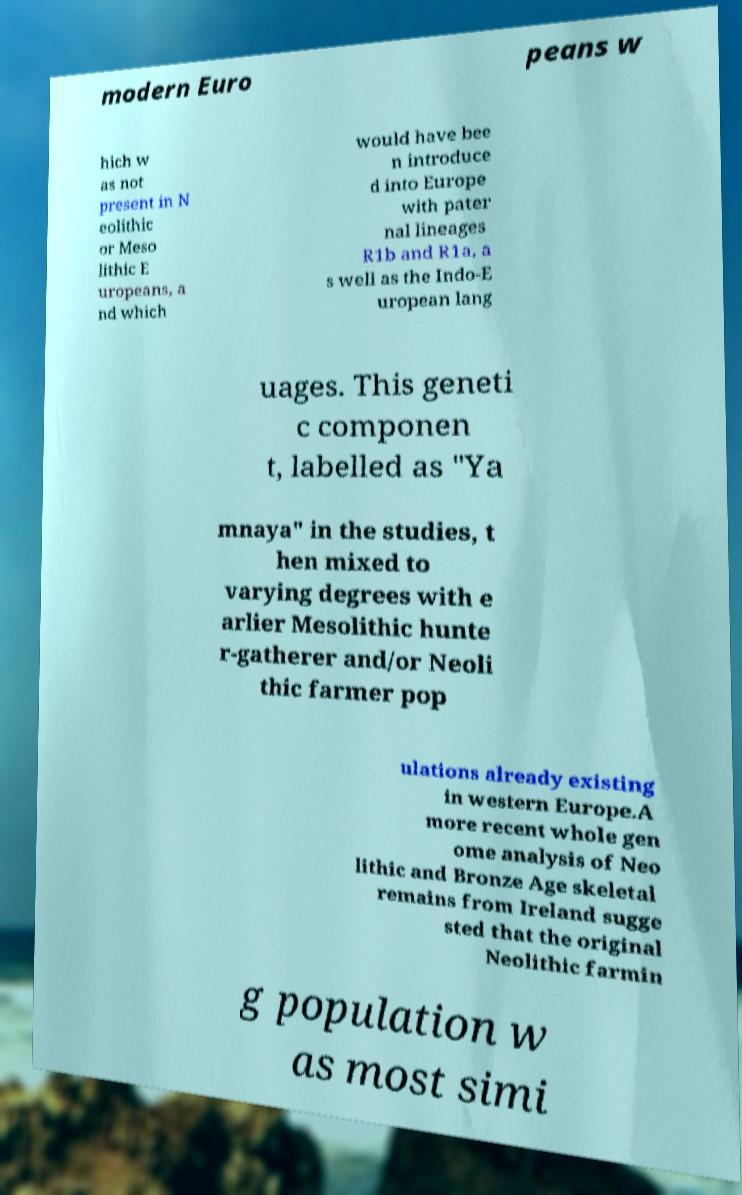For documentation purposes, I need the text within this image transcribed. Could you provide that? modern Euro peans w hich w as not present in N eolithic or Meso lithic E uropeans, a nd which would have bee n introduce d into Europe with pater nal lineages R1b and R1a, a s well as the Indo-E uropean lang uages. This geneti c componen t, labelled as "Ya mnaya" in the studies, t hen mixed to varying degrees with e arlier Mesolithic hunte r-gatherer and/or Neoli thic farmer pop ulations already existing in western Europe.A more recent whole gen ome analysis of Neo lithic and Bronze Age skeletal remains from Ireland sugge sted that the original Neolithic farmin g population w as most simi 